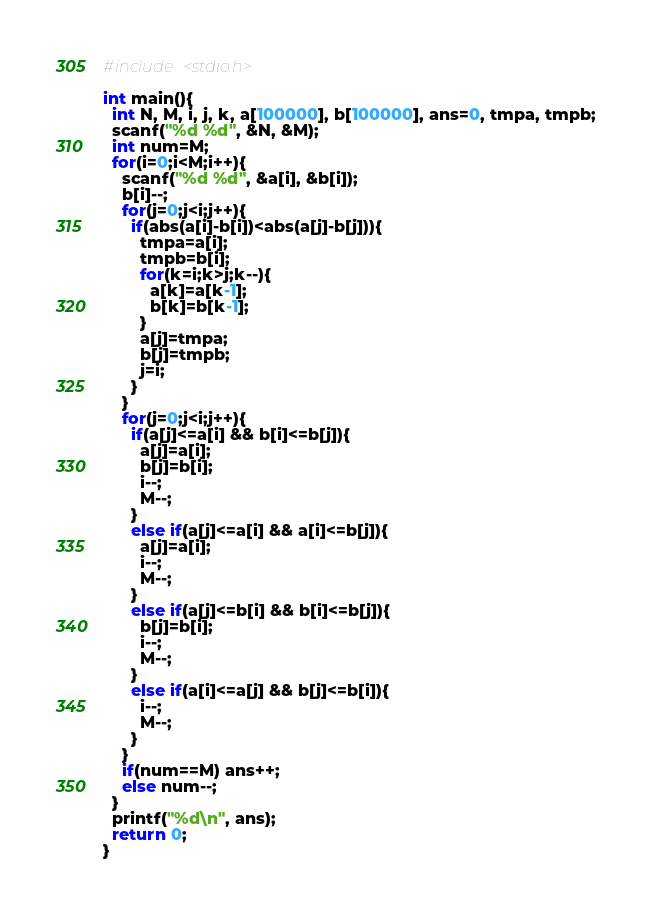Convert code to text. <code><loc_0><loc_0><loc_500><loc_500><_C_>#include <stdio.h>

int main(){
  int N, M, i, j, k, a[100000], b[100000], ans=0, tmpa, tmpb;
  scanf("%d %d", &N, &M);
  int num=M;
  for(i=0;i<M;i++){
    scanf("%d %d", &a[i], &b[i]);
    b[i]--;
    for(j=0;j<i;j++){
      if(abs(a[i]-b[i])<abs(a[j]-b[j])){
        tmpa=a[i];
        tmpb=b[i];
        for(k=i;k>j;k--){
          a[k]=a[k-1];
          b[k]=b[k-1];
        }
        a[j]=tmpa;
        b[j]=tmpb;
        j=i;
      }
    }
    for(j=0;j<i;j++){
      if(a[j]<=a[i] && b[i]<=b[j]){
        a[j]=a[i];
        b[j]=b[i];
        i--;
        M--;
      }
      else if(a[j]<=a[i] && a[i]<=b[j]){
        a[j]=a[i];
        i--;
        M--;
      }
      else if(a[j]<=b[i] && b[i]<=b[j]){
        b[j]=b[i];
        i--;
        M--;
      }
      else if(a[i]<=a[j] && b[j]<=b[i]){
        i--;
        M--;
      }
    }
    if(num==M) ans++;
    else num--;
  }
  printf("%d\n", ans);
  return 0;
}</code> 